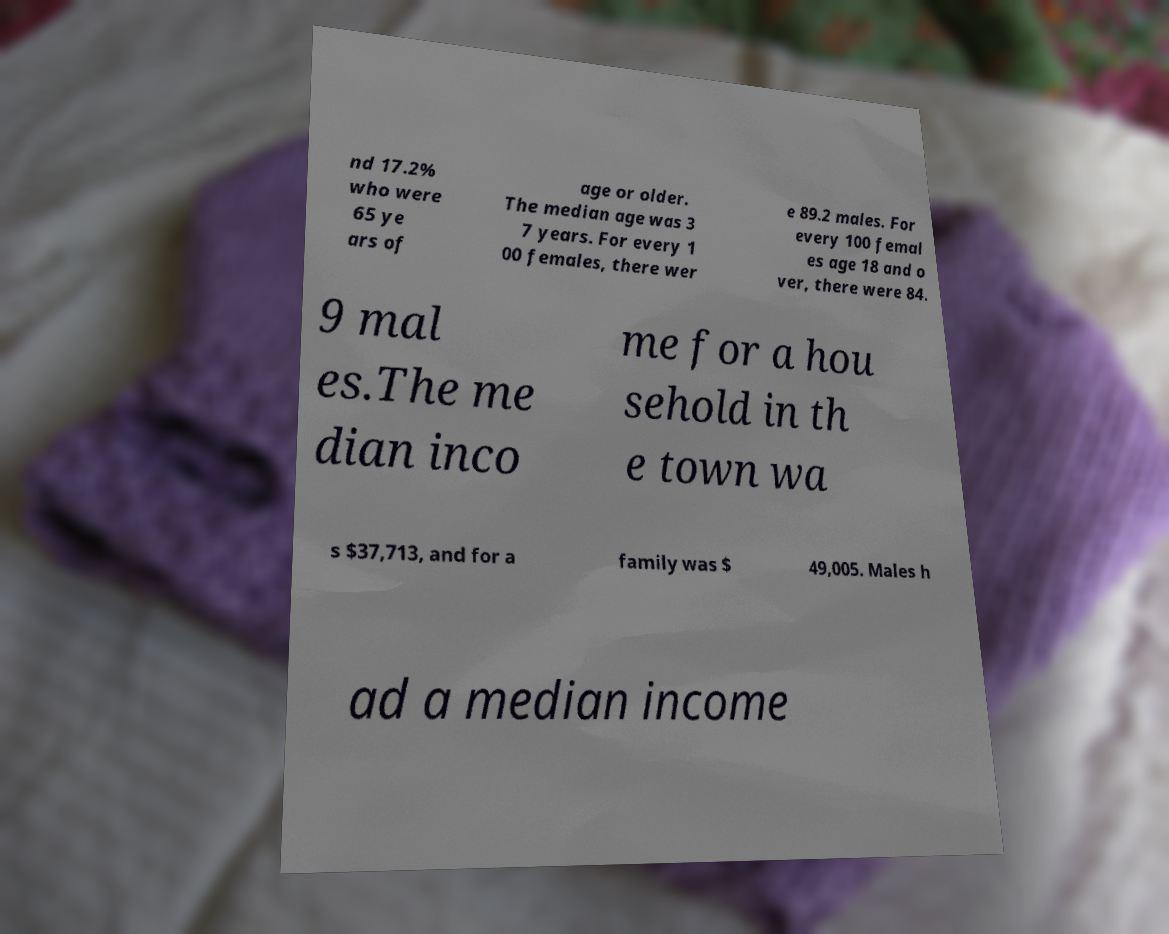Can you read and provide the text displayed in the image?This photo seems to have some interesting text. Can you extract and type it out for me? nd 17.2% who were 65 ye ars of age or older. The median age was 3 7 years. For every 1 00 females, there wer e 89.2 males. For every 100 femal es age 18 and o ver, there were 84. 9 mal es.The me dian inco me for a hou sehold in th e town wa s $37,713, and for a family was $ 49,005. Males h ad a median income 